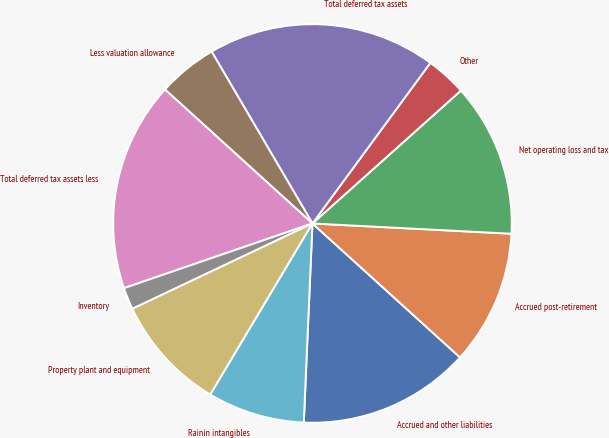<chart> <loc_0><loc_0><loc_500><loc_500><pie_chart><fcel>Accrued and other liabilities<fcel>Accrued post-retirement<fcel>Net operating loss and tax<fcel>Other<fcel>Total deferred tax assets<fcel>Less valuation allowance<fcel>Total deferred tax assets less<fcel>Inventory<fcel>Property plant and equipment<fcel>Rainin intangibles<nl><fcel>13.96%<fcel>10.91%<fcel>12.44%<fcel>3.3%<fcel>18.52%<fcel>4.82%<fcel>17.0%<fcel>1.78%<fcel>9.39%<fcel>7.87%<nl></chart> 